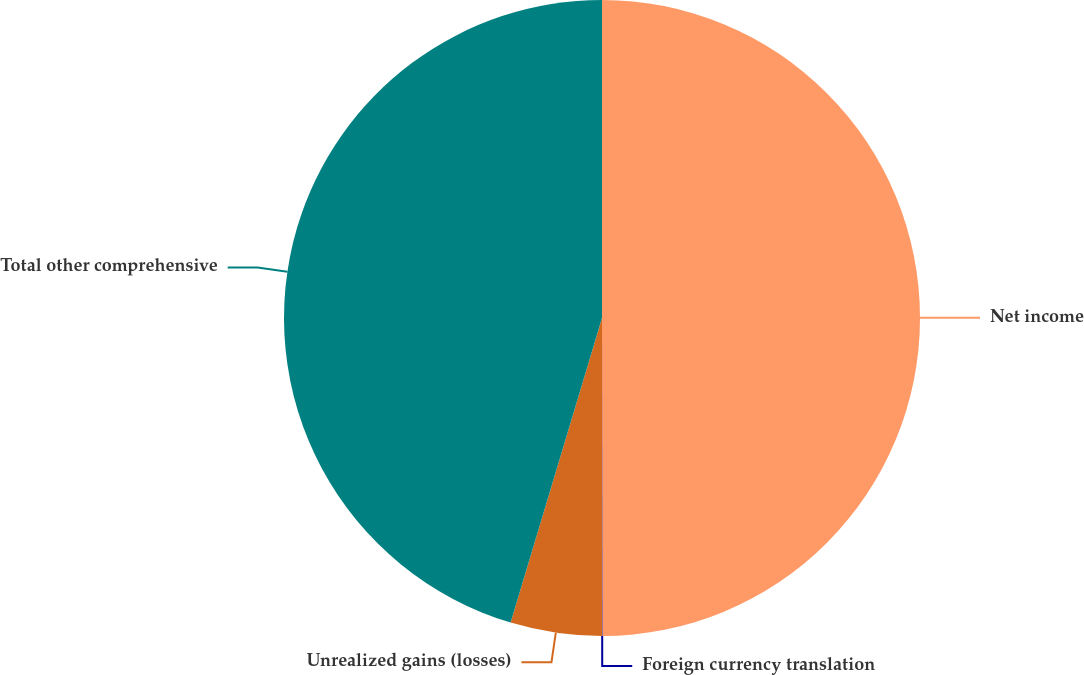Convert chart to OTSL. <chart><loc_0><loc_0><loc_500><loc_500><pie_chart><fcel>Net income<fcel>Foreign currency translation<fcel>Unrealized gains (losses)<fcel>Total other comprehensive<nl><fcel>49.98%<fcel>0.02%<fcel>4.64%<fcel>45.36%<nl></chart> 